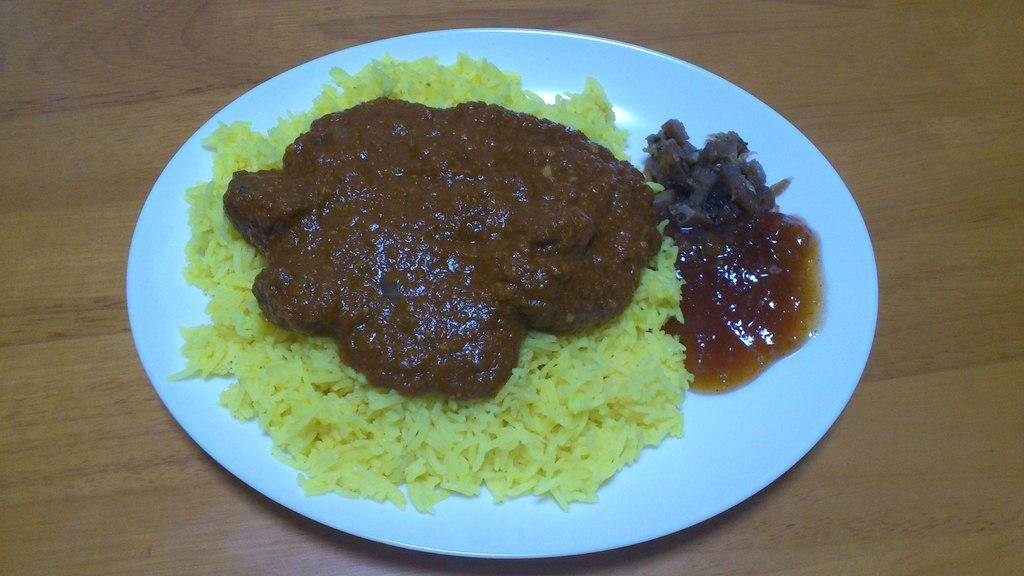What is on the plate that is visible in the image? The plate contains rice and curry. Where is the plate located in the image? The plate is placed on a table. What type of apple is used in the curry on the plate? There is no apple present in the image; the plate contains rice and curry. 